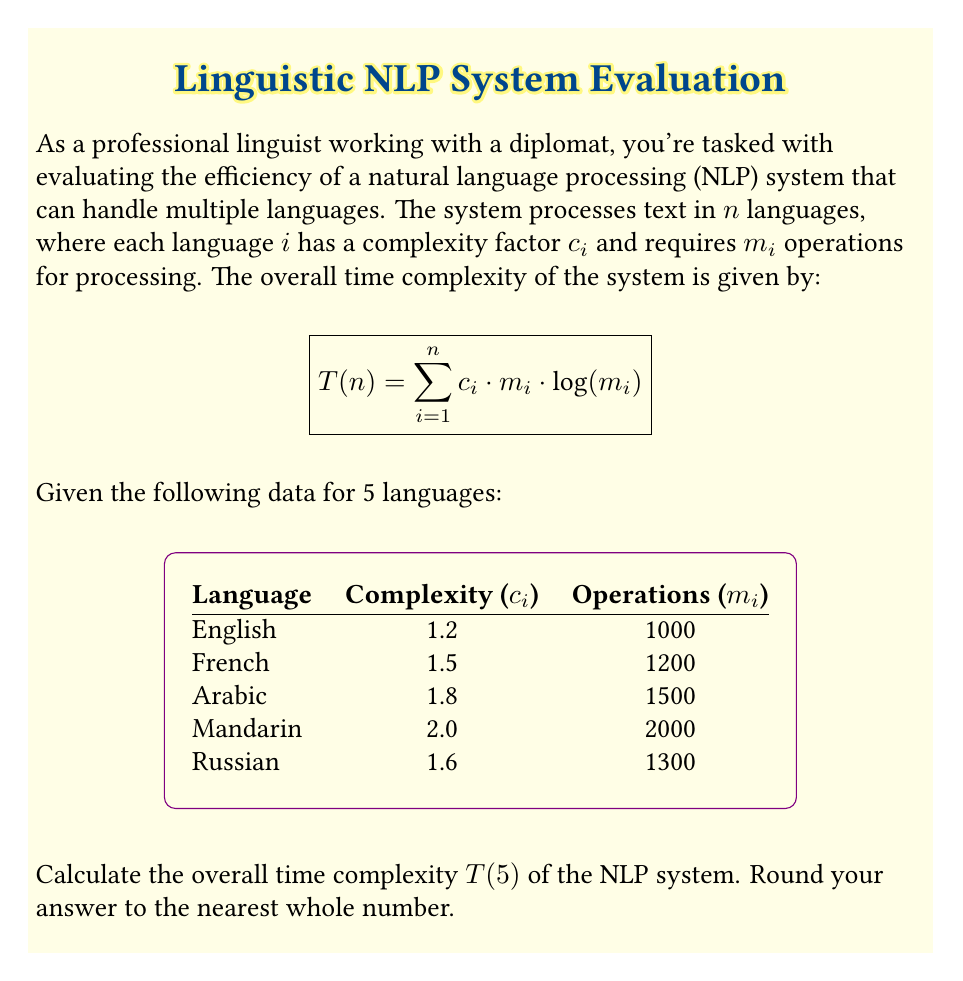Can you answer this question? To calculate the overall time complexity $T(5)$, we need to apply the given formula:

$$T(n) = \sum_{i=1}^n c_i \cdot m_i \cdot \log(m_i)$$

Let's calculate this for each language:

1. English: $T_1 = 1.2 \cdot 1000 \cdot \log(1000) = 1200 \cdot \log(1000) = 3605.17$

2. French: $T_2 = 1.5 \cdot 1200 \cdot \log(1200) = 1800 \cdot \log(1200) = 5860.29$

3. Arabic: $T_3 = 1.8 \cdot 1500 \cdot \log(1500) = 2700 \cdot \log(1500) = 9464.39$

4. Mandarin: $T_4 = 2.0 \cdot 2000 \cdot \log(2000) = 4000 \cdot \log(2000) = 14728.77$

5. Russian: $T_5 = 1.6 \cdot 1300 \cdot \log(1300) = 2080 \cdot \log(1300) = 6670.99$

Now, we sum up all these values:

$$T(5) = T_1 + T_2 + T_3 + T_4 + T_5$$
$$T(5) = 3605.17 + 5860.29 + 9464.39 + 14728.77 + 6670.99$$
$$T(5) = 40329.61$$

Rounding to the nearest whole number, we get 40330.
Answer: 40330 